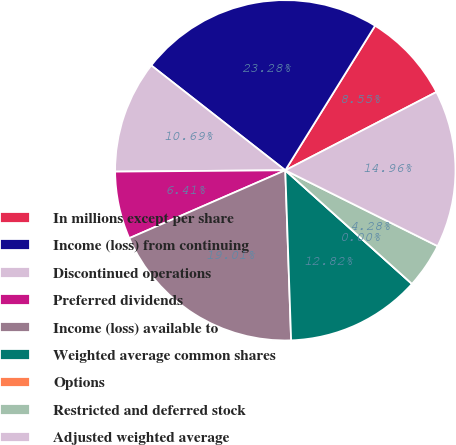Convert chart. <chart><loc_0><loc_0><loc_500><loc_500><pie_chart><fcel>In millions except per share<fcel>Income (loss) from continuing<fcel>Discontinued operations<fcel>Preferred dividends<fcel>Income (loss) available to<fcel>Weighted average common shares<fcel>Options<fcel>Restricted and deferred stock<fcel>Adjusted weighted average<nl><fcel>8.55%<fcel>23.28%<fcel>10.69%<fcel>6.41%<fcel>19.01%<fcel>12.82%<fcel>0.0%<fcel>4.28%<fcel>14.96%<nl></chart> 